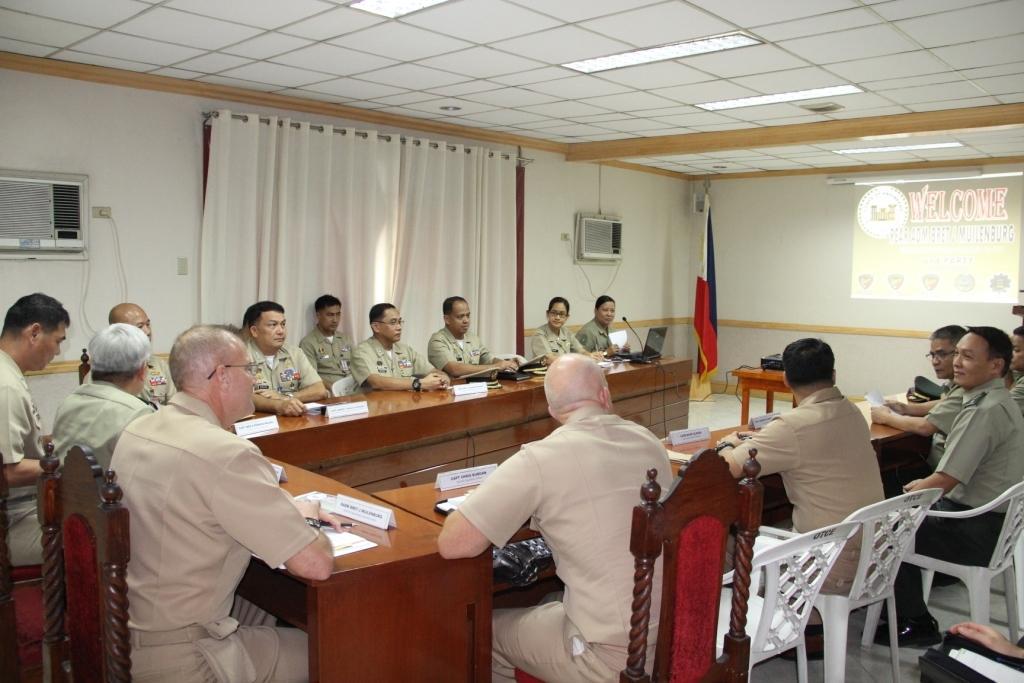Describe this image in one or two sentences. A group of army officers are sitting around a table and discussing. There are some women in the group. There is a screen in the front. 